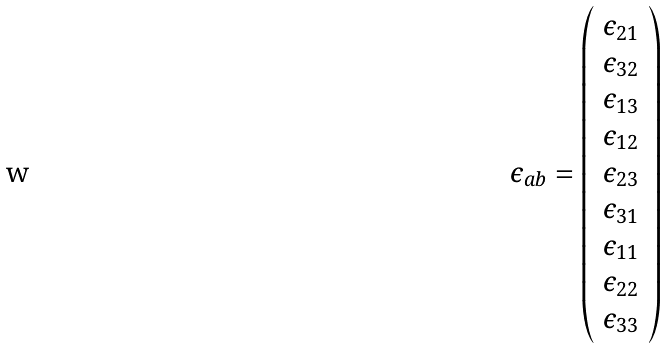Convert formula to latex. <formula><loc_0><loc_0><loc_500><loc_500>\epsilon _ { a b } = \left ( \begin{array} { c } \epsilon _ { 2 1 } \\ \epsilon _ { 3 2 } \\ \epsilon _ { 1 3 } \\ \epsilon _ { 1 2 } \\ \epsilon _ { 2 3 } \\ \epsilon _ { 3 1 } \\ \epsilon _ { 1 1 } \\ \epsilon _ { 2 2 } \\ \epsilon _ { 3 3 } \\ \end{array} \right )</formula> 